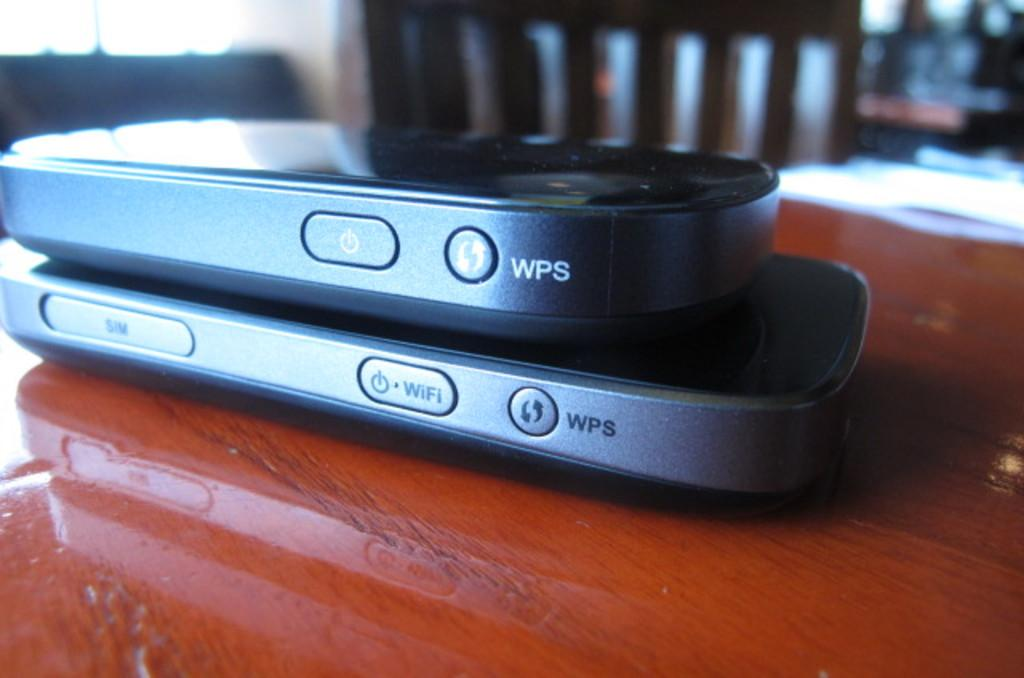<image>
Create a compact narrative representing the image presented. Two WPS devices are sitting on a wooden table 